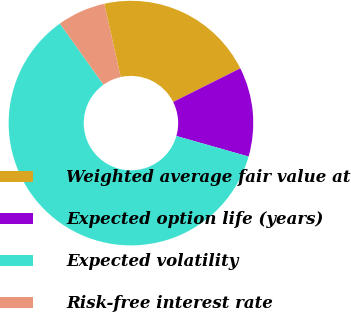<chart> <loc_0><loc_0><loc_500><loc_500><pie_chart><fcel>Weighted average fair value at<fcel>Expected option life (years)<fcel>Expected volatility<fcel>Risk-free interest rate<nl><fcel>21.11%<fcel>11.8%<fcel>60.72%<fcel>6.37%<nl></chart> 